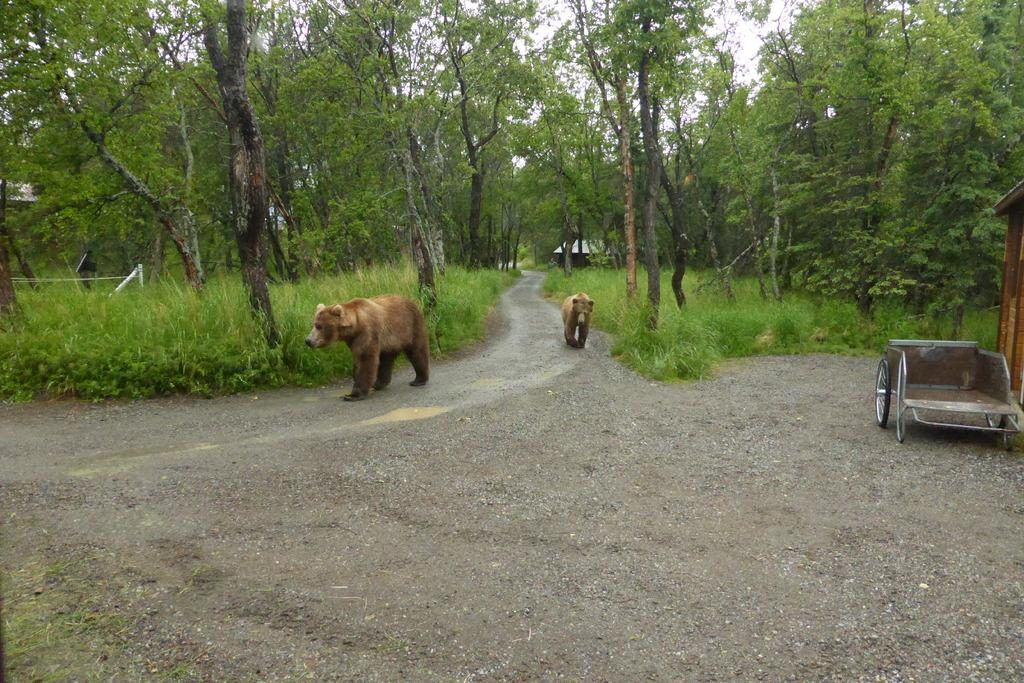What animals are on the road in the image? There are two bears on the road in the image. What can be seen on the right side of the image? There is a wheel cart on the right side of the image. What type of vegetation is present in the image? There are plants and trees in the image. What type of structure is visible in the image? There is a house in the image. What is visible in the background of the image? The sky is visible in the background of the image. Can you tell me the credit score of the bears in the image? There is no information about the credit score of the bears in the image, as credit scores are not applicable to bears. What type of joke is being told by the trees in the image? There is no joke being told by the trees in the image, as trees do not have the ability to tell jokes. 